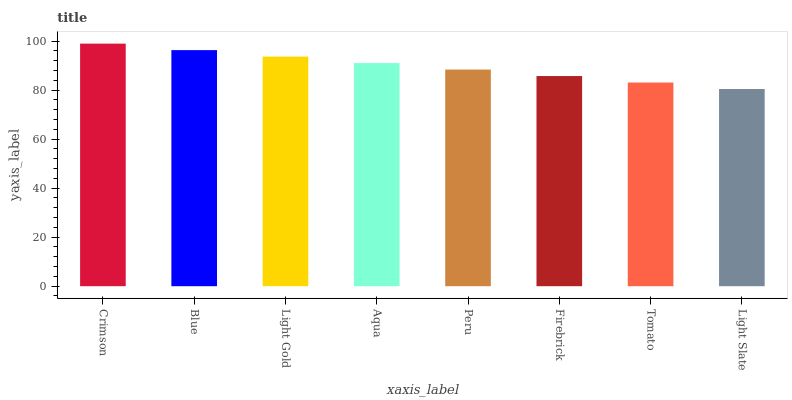Is Light Slate the minimum?
Answer yes or no. Yes. Is Crimson the maximum?
Answer yes or no. Yes. Is Blue the minimum?
Answer yes or no. No. Is Blue the maximum?
Answer yes or no. No. Is Crimson greater than Blue?
Answer yes or no. Yes. Is Blue less than Crimson?
Answer yes or no. Yes. Is Blue greater than Crimson?
Answer yes or no. No. Is Crimson less than Blue?
Answer yes or no. No. Is Aqua the high median?
Answer yes or no. Yes. Is Peru the low median?
Answer yes or no. Yes. Is Tomato the high median?
Answer yes or no. No. Is Aqua the low median?
Answer yes or no. No. 